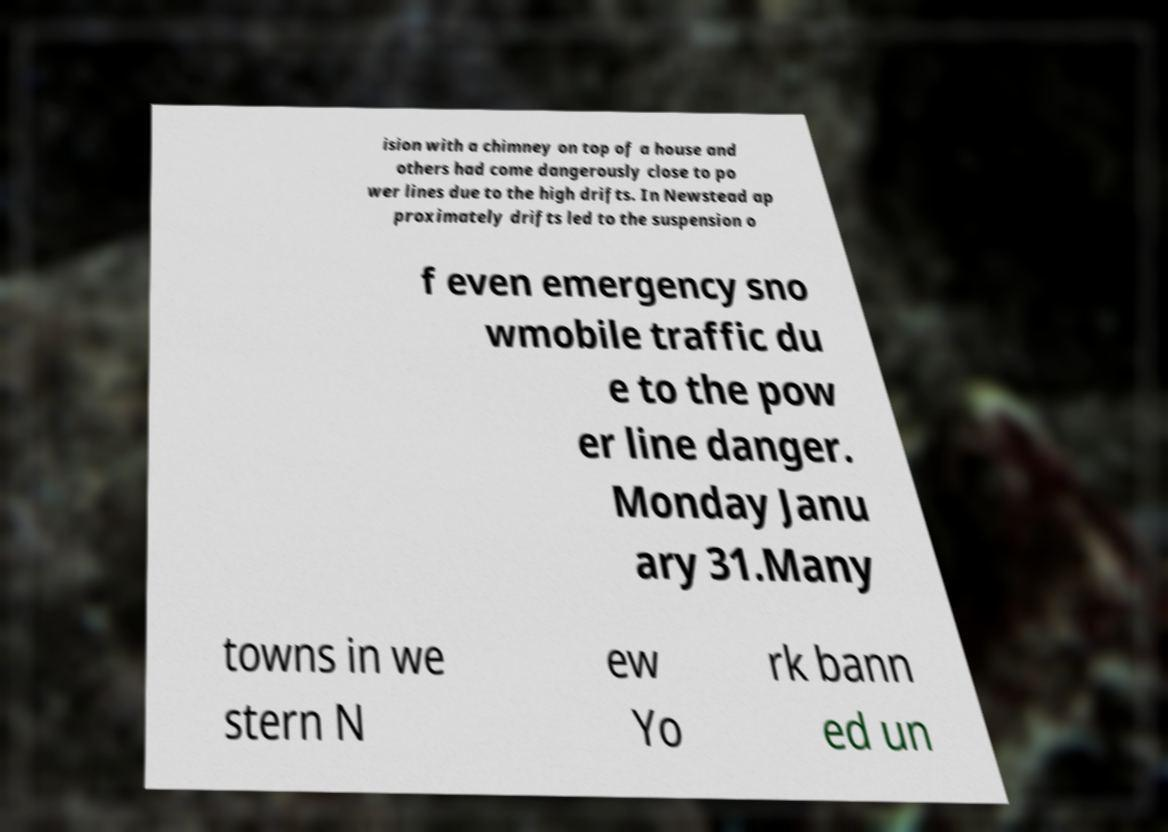For documentation purposes, I need the text within this image transcribed. Could you provide that? ision with a chimney on top of a house and others had come dangerously close to po wer lines due to the high drifts. In Newstead ap proximately drifts led to the suspension o f even emergency sno wmobile traffic du e to the pow er line danger. Monday Janu ary 31.Many towns in we stern N ew Yo rk bann ed un 